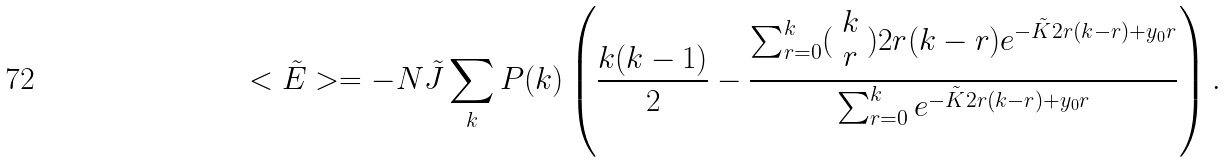<formula> <loc_0><loc_0><loc_500><loc_500>< \tilde { E } > = - N \tilde { J } \sum _ { k } P ( k ) \left ( \frac { k ( k - 1 ) } { 2 } - \frac { \sum _ { r = 0 } ^ { k } ( \begin{array} { c } k \\ r \\ \end{array} ) 2 r ( k - r ) e ^ { - \tilde { K } 2 r ( k - r ) + y _ { 0 } r } } { \sum _ { r = 0 } ^ { k } e ^ { - \tilde { K } 2 r ( k - r ) + y _ { 0 } r } } \right ) .</formula> 